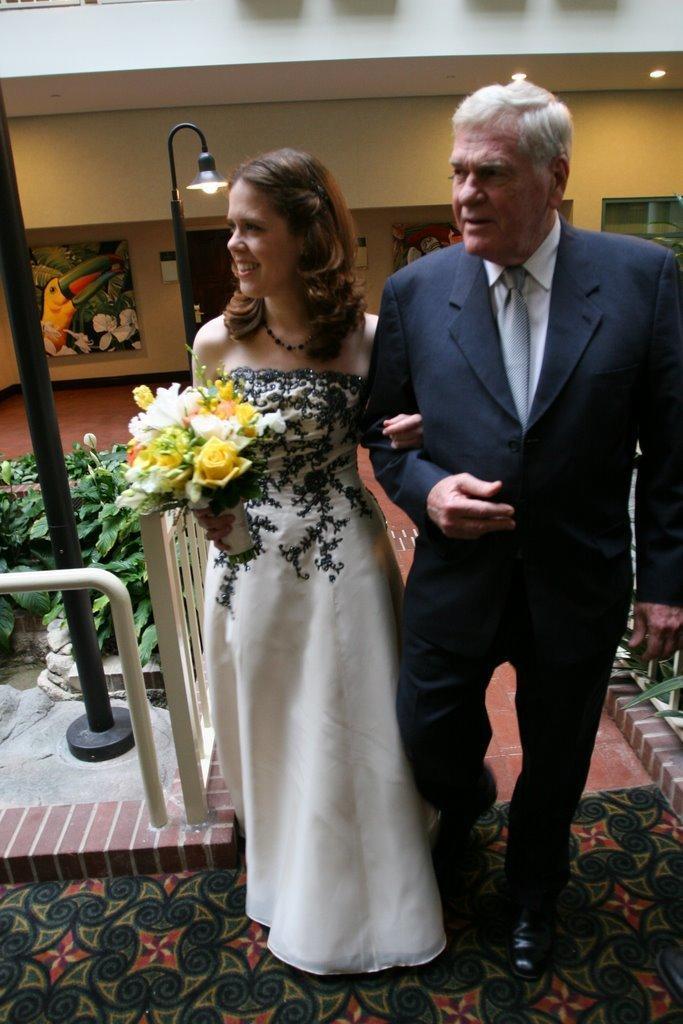Can you describe this image briefly? In this image we can see there are two persons walking on the floor and the other person holding a flower bogey. And we can see there are plants, railing, light pole and mat. In the background, we can see the wall with the door and photo frames. 